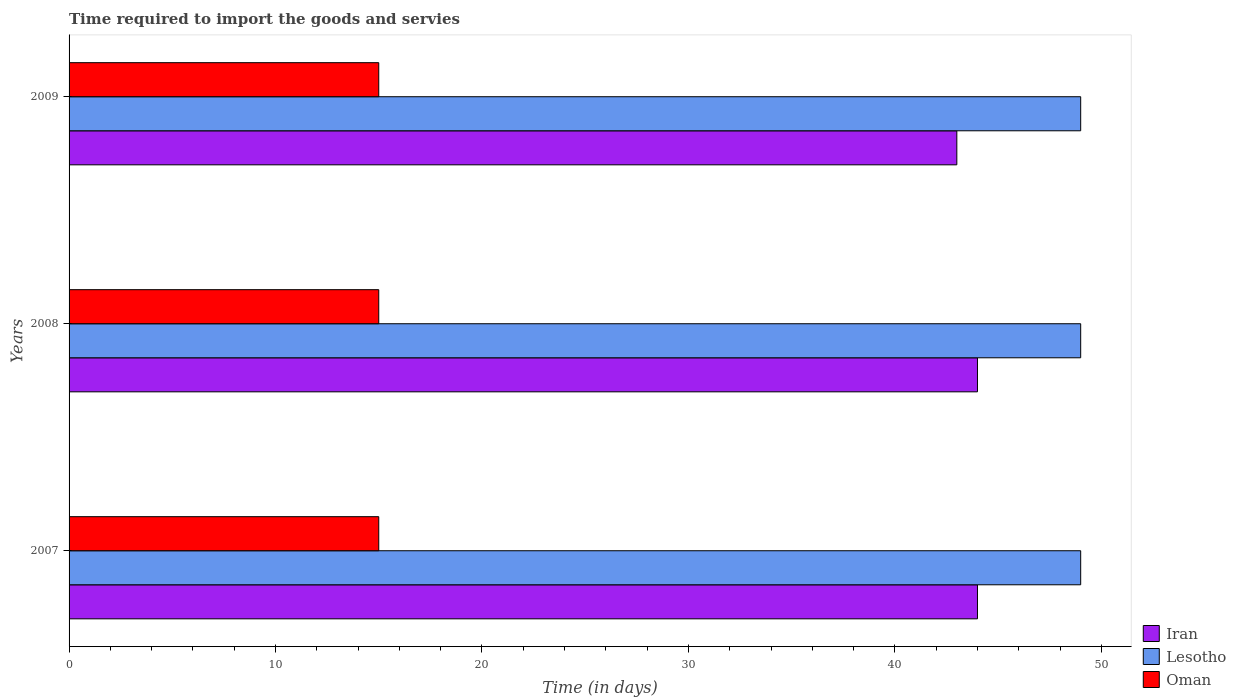How many groups of bars are there?
Ensure brevity in your answer.  3. Are the number of bars per tick equal to the number of legend labels?
Provide a short and direct response. Yes. How many bars are there on the 2nd tick from the bottom?
Offer a very short reply. 3. What is the label of the 3rd group of bars from the top?
Offer a terse response. 2007. In how many cases, is the number of bars for a given year not equal to the number of legend labels?
Offer a terse response. 0. What is the number of days required to import the goods and services in Lesotho in 2007?
Keep it short and to the point. 49. Across all years, what is the maximum number of days required to import the goods and services in Oman?
Ensure brevity in your answer.  15. Across all years, what is the minimum number of days required to import the goods and services in Iran?
Provide a short and direct response. 43. In which year was the number of days required to import the goods and services in Lesotho maximum?
Your response must be concise. 2007. In which year was the number of days required to import the goods and services in Iran minimum?
Offer a terse response. 2009. What is the total number of days required to import the goods and services in Lesotho in the graph?
Ensure brevity in your answer.  147. What is the difference between the number of days required to import the goods and services in Lesotho in 2009 and the number of days required to import the goods and services in Iran in 2007?
Ensure brevity in your answer.  5. In the year 2007, what is the difference between the number of days required to import the goods and services in Oman and number of days required to import the goods and services in Lesotho?
Offer a terse response. -34. In how many years, is the number of days required to import the goods and services in Lesotho greater than 2 days?
Provide a succinct answer. 3. What is the ratio of the number of days required to import the goods and services in Oman in 2007 to that in 2008?
Offer a terse response. 1. Is the number of days required to import the goods and services in Oman in 2008 less than that in 2009?
Provide a short and direct response. No. What is the difference between the highest and the second highest number of days required to import the goods and services in Lesotho?
Your answer should be very brief. 0. What is the difference between the highest and the lowest number of days required to import the goods and services in Iran?
Offer a terse response. 1. Is the sum of the number of days required to import the goods and services in Lesotho in 2007 and 2008 greater than the maximum number of days required to import the goods and services in Iran across all years?
Your response must be concise. Yes. What does the 1st bar from the top in 2007 represents?
Give a very brief answer. Oman. What does the 2nd bar from the bottom in 2007 represents?
Offer a terse response. Lesotho. Is it the case that in every year, the sum of the number of days required to import the goods and services in Lesotho and number of days required to import the goods and services in Oman is greater than the number of days required to import the goods and services in Iran?
Your response must be concise. Yes. Are all the bars in the graph horizontal?
Your response must be concise. Yes. What is the difference between two consecutive major ticks on the X-axis?
Keep it short and to the point. 10. What is the title of the graph?
Your answer should be compact. Time required to import the goods and servies. Does "Philippines" appear as one of the legend labels in the graph?
Ensure brevity in your answer.  No. What is the label or title of the X-axis?
Your answer should be compact. Time (in days). What is the label or title of the Y-axis?
Your answer should be compact. Years. What is the Time (in days) of Oman in 2007?
Your response must be concise. 15. What is the Time (in days) in Iran in 2008?
Give a very brief answer. 44. What is the Time (in days) in Oman in 2008?
Your answer should be compact. 15. Across all years, what is the maximum Time (in days) in Lesotho?
Keep it short and to the point. 49. Across all years, what is the minimum Time (in days) in Iran?
Your response must be concise. 43. What is the total Time (in days) in Iran in the graph?
Your response must be concise. 131. What is the total Time (in days) of Lesotho in the graph?
Keep it short and to the point. 147. What is the difference between the Time (in days) of Iran in 2007 and that in 2008?
Make the answer very short. 0. What is the difference between the Time (in days) in Lesotho in 2007 and that in 2008?
Your answer should be very brief. 0. What is the difference between the Time (in days) of Oman in 2007 and that in 2008?
Your answer should be compact. 0. What is the difference between the Time (in days) of Lesotho in 2007 and that in 2009?
Give a very brief answer. 0. What is the difference between the Time (in days) in Lesotho in 2008 and that in 2009?
Keep it short and to the point. 0. What is the difference between the Time (in days) of Oman in 2008 and that in 2009?
Ensure brevity in your answer.  0. What is the difference between the Time (in days) of Iran in 2007 and the Time (in days) of Oman in 2008?
Your answer should be compact. 29. What is the difference between the Time (in days) in Lesotho in 2007 and the Time (in days) in Oman in 2008?
Ensure brevity in your answer.  34. What is the difference between the Time (in days) in Iran in 2007 and the Time (in days) in Lesotho in 2009?
Ensure brevity in your answer.  -5. What is the difference between the Time (in days) of Iran in 2007 and the Time (in days) of Oman in 2009?
Your answer should be very brief. 29. What is the difference between the Time (in days) of Lesotho in 2008 and the Time (in days) of Oman in 2009?
Your answer should be compact. 34. What is the average Time (in days) in Iran per year?
Give a very brief answer. 43.67. What is the average Time (in days) in Oman per year?
Offer a very short reply. 15. In the year 2007, what is the difference between the Time (in days) in Iran and Time (in days) in Oman?
Provide a succinct answer. 29. In the year 2007, what is the difference between the Time (in days) in Lesotho and Time (in days) in Oman?
Offer a terse response. 34. In the year 2008, what is the difference between the Time (in days) in Lesotho and Time (in days) in Oman?
Ensure brevity in your answer.  34. In the year 2009, what is the difference between the Time (in days) of Iran and Time (in days) of Oman?
Your answer should be very brief. 28. What is the ratio of the Time (in days) in Iran in 2007 to that in 2008?
Your answer should be very brief. 1. What is the ratio of the Time (in days) of Iran in 2007 to that in 2009?
Provide a succinct answer. 1.02. What is the ratio of the Time (in days) of Oman in 2007 to that in 2009?
Ensure brevity in your answer.  1. What is the ratio of the Time (in days) in Iran in 2008 to that in 2009?
Offer a terse response. 1.02. What is the difference between the highest and the lowest Time (in days) in Iran?
Provide a succinct answer. 1. What is the difference between the highest and the lowest Time (in days) in Lesotho?
Your answer should be compact. 0. What is the difference between the highest and the lowest Time (in days) in Oman?
Make the answer very short. 0. 